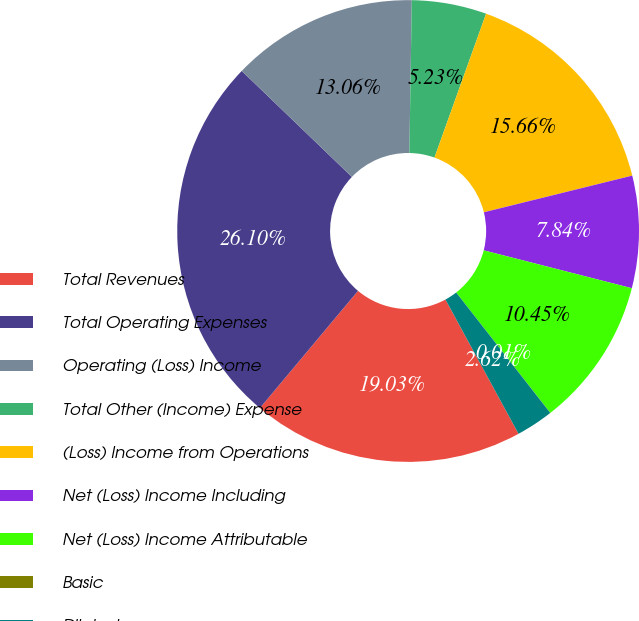Convert chart. <chart><loc_0><loc_0><loc_500><loc_500><pie_chart><fcel>Total Revenues<fcel>Total Operating Expenses<fcel>Operating (Loss) Income<fcel>Total Other (Income) Expense<fcel>(Loss) Income from Operations<fcel>Net (Loss) Income Including<fcel>Net (Loss) Income Attributable<fcel>Basic<fcel>Diluted<nl><fcel>19.03%<fcel>26.1%<fcel>13.06%<fcel>5.23%<fcel>15.66%<fcel>7.84%<fcel>10.45%<fcel>0.01%<fcel>2.62%<nl></chart> 